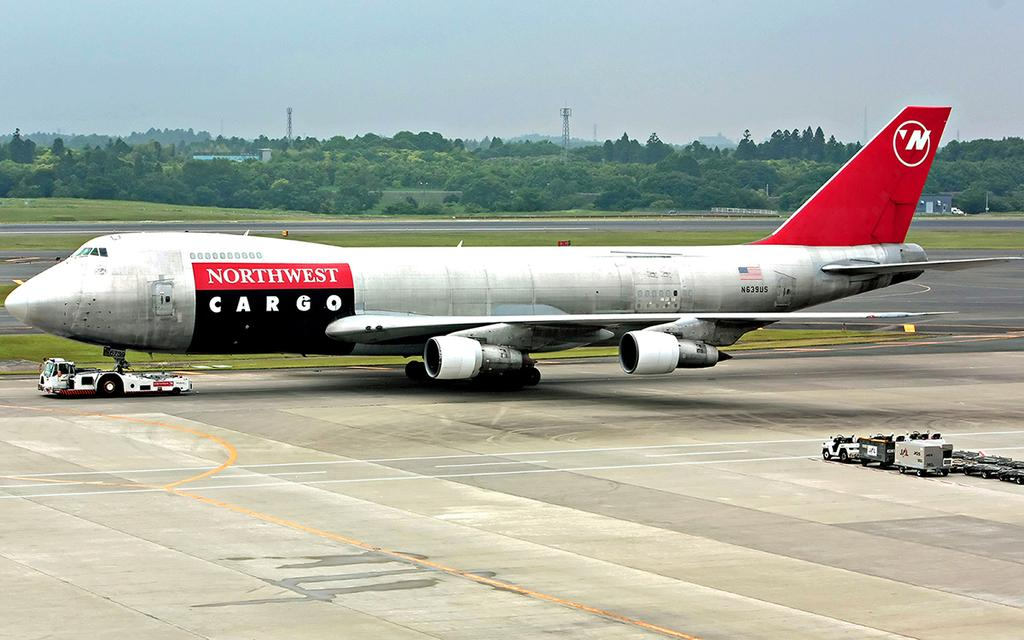<image>
Summarize the visual content of the image. A red and white Northwest Cargo plane on the ground. 